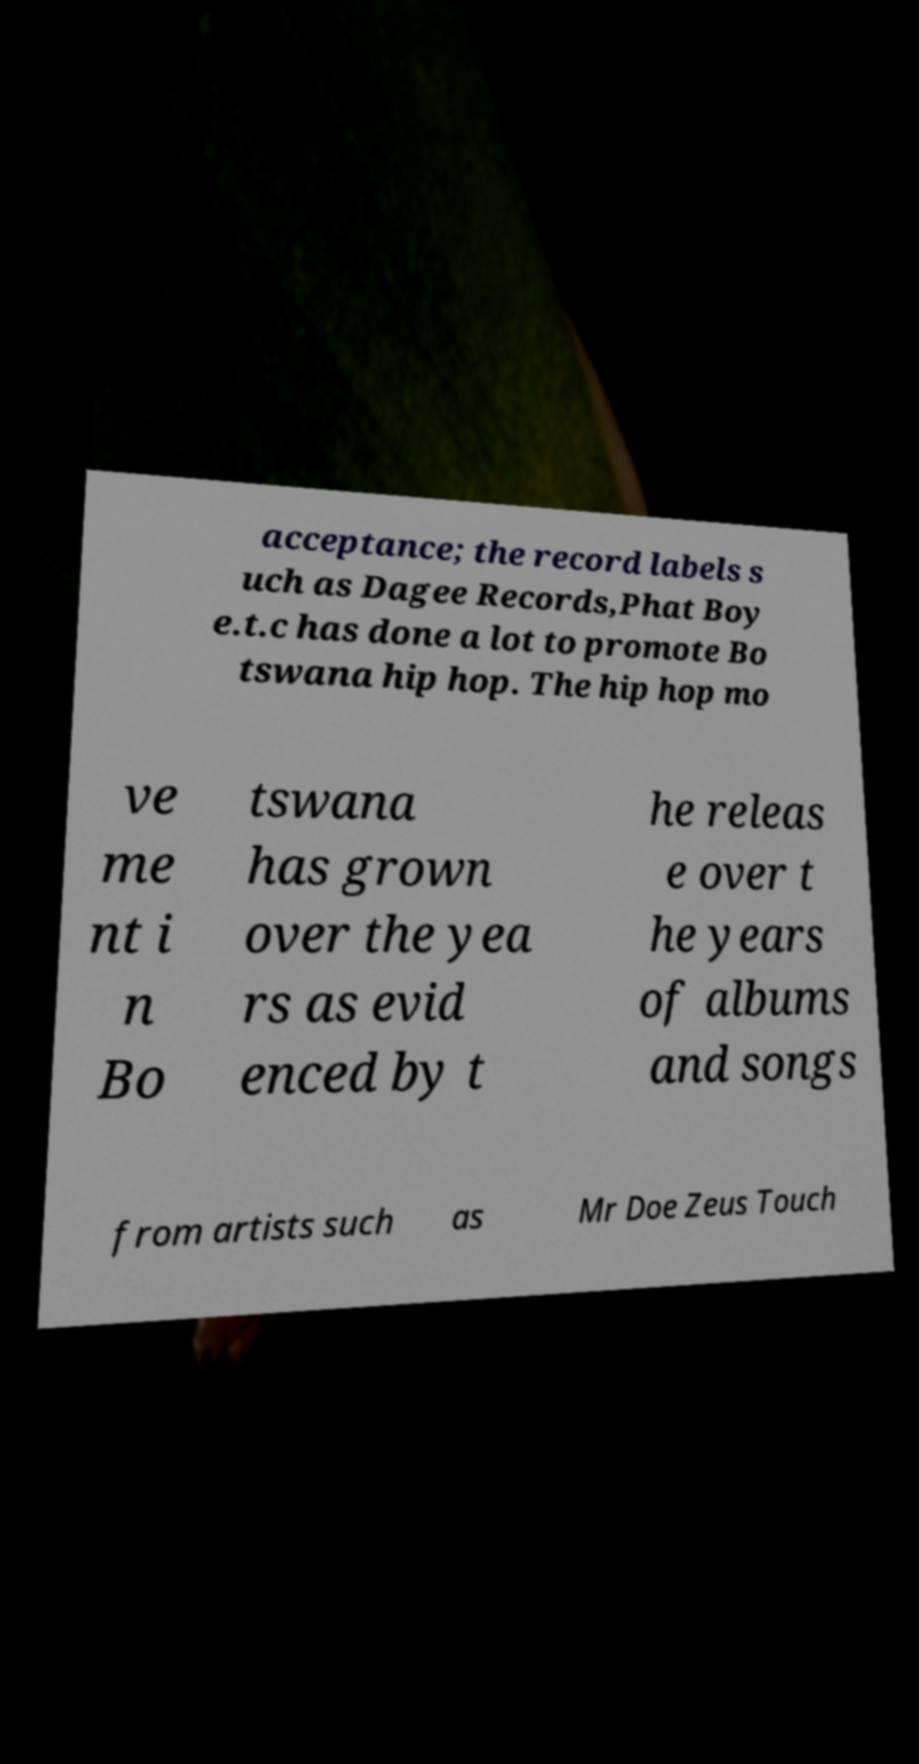Please identify and transcribe the text found in this image. acceptance; the record labels s uch as Dagee Records,Phat Boy e.t.c has done a lot to promote Bo tswana hip hop. The hip hop mo ve me nt i n Bo tswana has grown over the yea rs as evid enced by t he releas e over t he years of albums and songs from artists such as Mr Doe Zeus Touch 